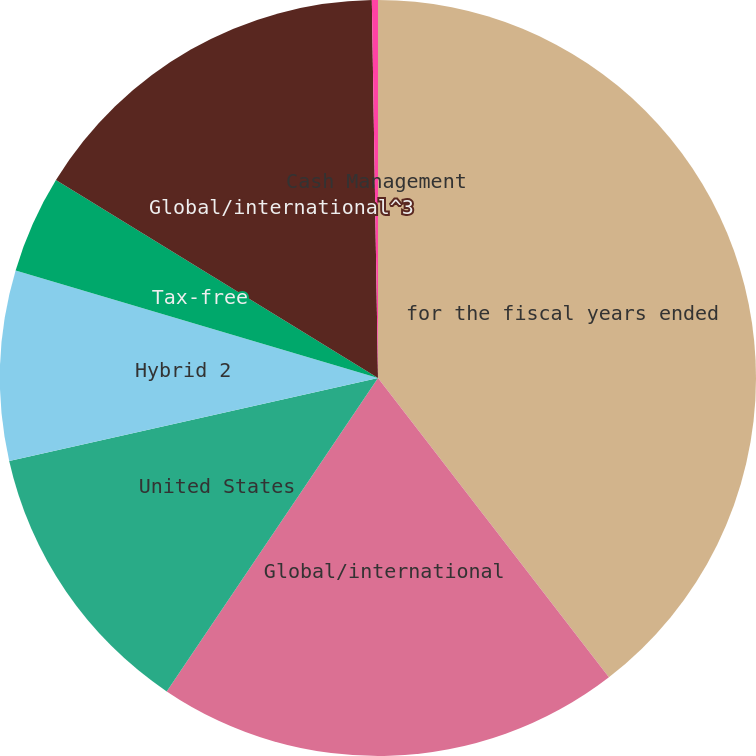Convert chart. <chart><loc_0><loc_0><loc_500><loc_500><pie_chart><fcel>for the fiscal years ended<fcel>Global/international<fcel>United States<fcel>Hybrid 2<fcel>Tax-free<fcel>Global/international^3<fcel>Cash Management<nl><fcel>39.54%<fcel>19.9%<fcel>12.04%<fcel>8.11%<fcel>4.18%<fcel>15.97%<fcel>0.26%<nl></chart> 